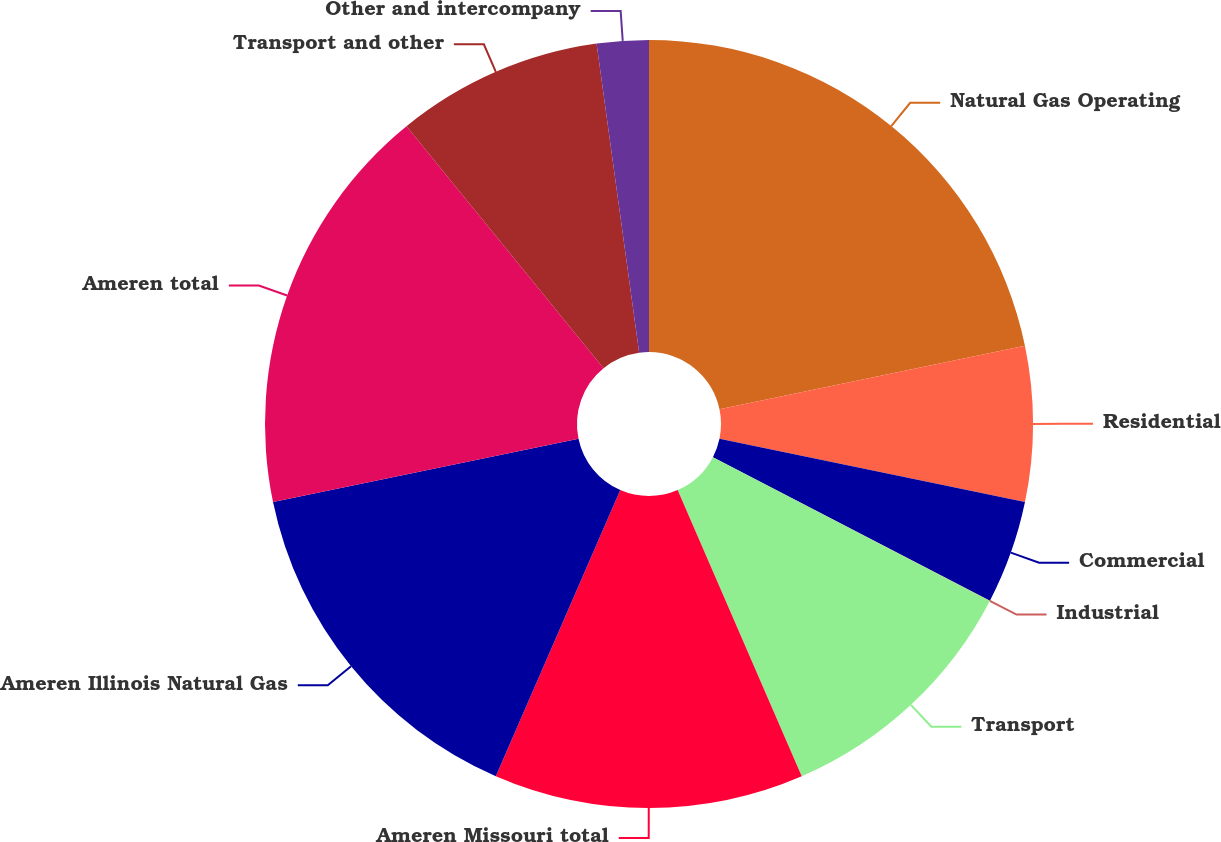<chart> <loc_0><loc_0><loc_500><loc_500><pie_chart><fcel>Natural Gas Operating<fcel>Residential<fcel>Commercial<fcel>Industrial<fcel>Transport<fcel>Ameren Missouri total<fcel>Ameren Illinois Natural Gas<fcel>Ameren total<fcel>Transport and other<fcel>Other and intercompany<nl><fcel>21.73%<fcel>6.53%<fcel>4.35%<fcel>0.01%<fcel>10.87%<fcel>13.04%<fcel>15.21%<fcel>17.38%<fcel>8.7%<fcel>2.18%<nl></chart> 